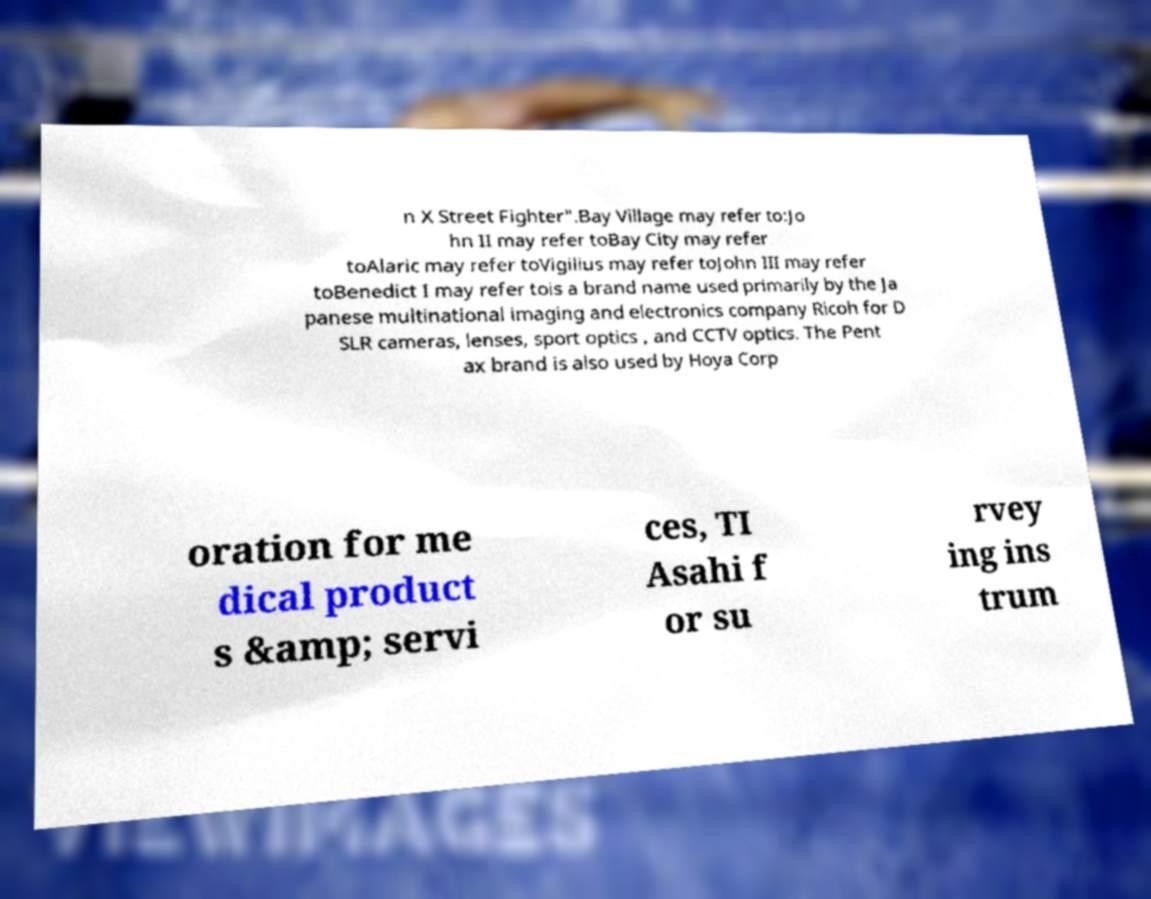Could you extract and type out the text from this image? n X Street Fighter".Bay Village may refer to:Jo hn II may refer toBay City may refer toAlaric may refer toVigilius may refer toJohn III may refer toBenedict I may refer tois a brand name used primarily by the Ja panese multinational imaging and electronics company Ricoh for D SLR cameras, lenses, sport optics , and CCTV optics. The Pent ax brand is also used by Hoya Corp oration for me dical product s &amp; servi ces, TI Asahi f or su rvey ing ins trum 